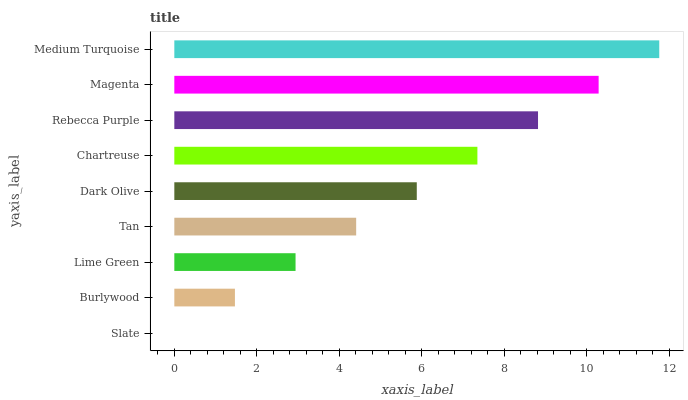Is Slate the minimum?
Answer yes or no. Yes. Is Medium Turquoise the maximum?
Answer yes or no. Yes. Is Burlywood the minimum?
Answer yes or no. No. Is Burlywood the maximum?
Answer yes or no. No. Is Burlywood greater than Slate?
Answer yes or no. Yes. Is Slate less than Burlywood?
Answer yes or no. Yes. Is Slate greater than Burlywood?
Answer yes or no. No. Is Burlywood less than Slate?
Answer yes or no. No. Is Dark Olive the high median?
Answer yes or no. Yes. Is Dark Olive the low median?
Answer yes or no. Yes. Is Slate the high median?
Answer yes or no. No. Is Rebecca Purple the low median?
Answer yes or no. No. 